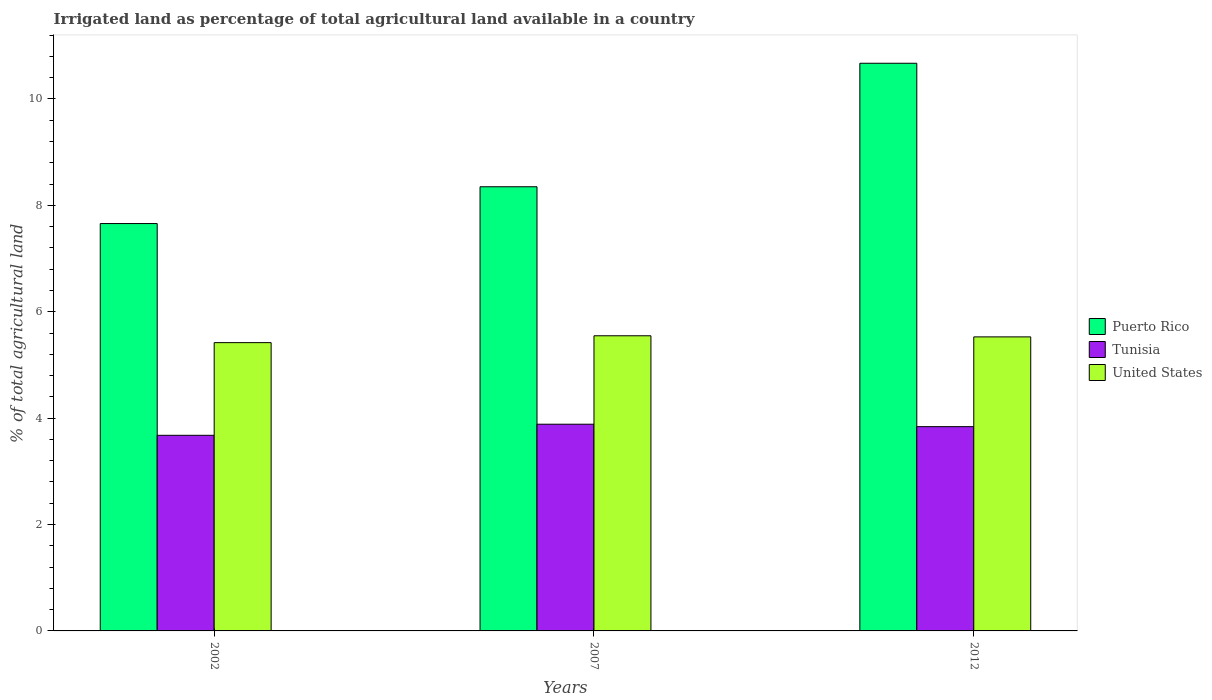Are the number of bars per tick equal to the number of legend labels?
Provide a succinct answer. Yes. Are the number of bars on each tick of the X-axis equal?
Your answer should be very brief. Yes. What is the label of the 3rd group of bars from the left?
Offer a terse response. 2012. In how many cases, is the number of bars for a given year not equal to the number of legend labels?
Your response must be concise. 0. What is the percentage of irrigated land in Tunisia in 2002?
Your response must be concise. 3.68. Across all years, what is the maximum percentage of irrigated land in Puerto Rico?
Keep it short and to the point. 10.67. Across all years, what is the minimum percentage of irrigated land in Puerto Rico?
Provide a short and direct response. 7.66. In which year was the percentage of irrigated land in United States minimum?
Offer a terse response. 2002. What is the total percentage of irrigated land in Tunisia in the graph?
Offer a terse response. 11.4. What is the difference between the percentage of irrigated land in United States in 2002 and that in 2007?
Provide a succinct answer. -0.13. What is the difference between the percentage of irrigated land in Puerto Rico in 2007 and the percentage of irrigated land in Tunisia in 2002?
Give a very brief answer. 4.67. What is the average percentage of irrigated land in Tunisia per year?
Your answer should be very brief. 3.8. In the year 2007, what is the difference between the percentage of irrigated land in Tunisia and percentage of irrigated land in United States?
Your response must be concise. -1.66. In how many years, is the percentage of irrigated land in Puerto Rico greater than 4.8 %?
Provide a succinct answer. 3. What is the ratio of the percentage of irrigated land in United States in 2007 to that in 2012?
Provide a short and direct response. 1. What is the difference between the highest and the second highest percentage of irrigated land in Tunisia?
Ensure brevity in your answer.  0.05. What is the difference between the highest and the lowest percentage of irrigated land in United States?
Offer a terse response. 0.13. In how many years, is the percentage of irrigated land in Puerto Rico greater than the average percentage of irrigated land in Puerto Rico taken over all years?
Ensure brevity in your answer.  1. What does the 2nd bar from the left in 2007 represents?
Offer a terse response. Tunisia. What does the 3rd bar from the right in 2012 represents?
Your response must be concise. Puerto Rico. How many years are there in the graph?
Offer a terse response. 3. What is the difference between two consecutive major ticks on the Y-axis?
Offer a terse response. 2. Are the values on the major ticks of Y-axis written in scientific E-notation?
Keep it short and to the point. No. How many legend labels are there?
Make the answer very short. 3. What is the title of the graph?
Provide a short and direct response. Irrigated land as percentage of total agricultural land available in a country. Does "Nepal" appear as one of the legend labels in the graph?
Your answer should be very brief. No. What is the label or title of the Y-axis?
Make the answer very short. % of total agricultural land. What is the % of total agricultural land of Puerto Rico in 2002?
Provide a succinct answer. 7.66. What is the % of total agricultural land in Tunisia in 2002?
Ensure brevity in your answer.  3.68. What is the % of total agricultural land of United States in 2002?
Offer a terse response. 5.42. What is the % of total agricultural land in Puerto Rico in 2007?
Your response must be concise. 8.35. What is the % of total agricultural land in Tunisia in 2007?
Offer a terse response. 3.89. What is the % of total agricultural land in United States in 2007?
Keep it short and to the point. 5.55. What is the % of total agricultural land in Puerto Rico in 2012?
Your response must be concise. 10.67. What is the % of total agricultural land of Tunisia in 2012?
Your answer should be very brief. 3.84. What is the % of total agricultural land in United States in 2012?
Offer a very short reply. 5.53. Across all years, what is the maximum % of total agricultural land of Puerto Rico?
Your answer should be compact. 10.67. Across all years, what is the maximum % of total agricultural land of Tunisia?
Ensure brevity in your answer.  3.89. Across all years, what is the maximum % of total agricultural land in United States?
Your answer should be compact. 5.55. Across all years, what is the minimum % of total agricultural land of Puerto Rico?
Give a very brief answer. 7.66. Across all years, what is the minimum % of total agricultural land in Tunisia?
Keep it short and to the point. 3.68. Across all years, what is the minimum % of total agricultural land of United States?
Offer a very short reply. 5.42. What is the total % of total agricultural land of Puerto Rico in the graph?
Offer a terse response. 26.68. What is the total % of total agricultural land of Tunisia in the graph?
Your answer should be compact. 11.4. What is the total % of total agricultural land in United States in the graph?
Your response must be concise. 16.49. What is the difference between the % of total agricultural land of Puerto Rico in 2002 and that in 2007?
Offer a very short reply. -0.69. What is the difference between the % of total agricultural land of Tunisia in 2002 and that in 2007?
Provide a succinct answer. -0.21. What is the difference between the % of total agricultural land in United States in 2002 and that in 2007?
Your response must be concise. -0.13. What is the difference between the % of total agricultural land of Puerto Rico in 2002 and that in 2012?
Offer a very short reply. -3.01. What is the difference between the % of total agricultural land in Tunisia in 2002 and that in 2012?
Your answer should be very brief. -0.16. What is the difference between the % of total agricultural land in United States in 2002 and that in 2012?
Your answer should be compact. -0.11. What is the difference between the % of total agricultural land in Puerto Rico in 2007 and that in 2012?
Keep it short and to the point. -2.32. What is the difference between the % of total agricultural land in Tunisia in 2007 and that in 2012?
Your response must be concise. 0.05. What is the difference between the % of total agricultural land in United States in 2007 and that in 2012?
Offer a very short reply. 0.02. What is the difference between the % of total agricultural land in Puerto Rico in 2002 and the % of total agricultural land in Tunisia in 2007?
Make the answer very short. 3.77. What is the difference between the % of total agricultural land in Puerto Rico in 2002 and the % of total agricultural land in United States in 2007?
Give a very brief answer. 2.11. What is the difference between the % of total agricultural land of Tunisia in 2002 and the % of total agricultural land of United States in 2007?
Your answer should be compact. -1.87. What is the difference between the % of total agricultural land in Puerto Rico in 2002 and the % of total agricultural land in Tunisia in 2012?
Give a very brief answer. 3.82. What is the difference between the % of total agricultural land of Puerto Rico in 2002 and the % of total agricultural land of United States in 2012?
Provide a succinct answer. 2.13. What is the difference between the % of total agricultural land of Tunisia in 2002 and the % of total agricultural land of United States in 2012?
Your answer should be compact. -1.85. What is the difference between the % of total agricultural land of Puerto Rico in 2007 and the % of total agricultural land of Tunisia in 2012?
Keep it short and to the point. 4.51. What is the difference between the % of total agricultural land in Puerto Rico in 2007 and the % of total agricultural land in United States in 2012?
Keep it short and to the point. 2.82. What is the difference between the % of total agricultural land in Tunisia in 2007 and the % of total agricultural land in United States in 2012?
Your answer should be very brief. -1.64. What is the average % of total agricultural land in Puerto Rico per year?
Your answer should be compact. 8.89. What is the average % of total agricultural land in Tunisia per year?
Your answer should be compact. 3.8. What is the average % of total agricultural land of United States per year?
Make the answer very short. 5.5. In the year 2002, what is the difference between the % of total agricultural land in Puerto Rico and % of total agricultural land in Tunisia?
Provide a short and direct response. 3.98. In the year 2002, what is the difference between the % of total agricultural land of Puerto Rico and % of total agricultural land of United States?
Keep it short and to the point. 2.24. In the year 2002, what is the difference between the % of total agricultural land of Tunisia and % of total agricultural land of United States?
Your response must be concise. -1.74. In the year 2007, what is the difference between the % of total agricultural land of Puerto Rico and % of total agricultural land of Tunisia?
Your answer should be compact. 4.46. In the year 2007, what is the difference between the % of total agricultural land of Puerto Rico and % of total agricultural land of United States?
Provide a short and direct response. 2.8. In the year 2007, what is the difference between the % of total agricultural land in Tunisia and % of total agricultural land in United States?
Ensure brevity in your answer.  -1.66. In the year 2012, what is the difference between the % of total agricultural land of Puerto Rico and % of total agricultural land of Tunisia?
Give a very brief answer. 6.83. In the year 2012, what is the difference between the % of total agricultural land in Puerto Rico and % of total agricultural land in United States?
Your response must be concise. 5.14. In the year 2012, what is the difference between the % of total agricultural land in Tunisia and % of total agricultural land in United States?
Keep it short and to the point. -1.69. What is the ratio of the % of total agricultural land in Puerto Rico in 2002 to that in 2007?
Give a very brief answer. 0.92. What is the ratio of the % of total agricultural land in Tunisia in 2002 to that in 2007?
Provide a succinct answer. 0.95. What is the ratio of the % of total agricultural land of United States in 2002 to that in 2007?
Offer a terse response. 0.98. What is the ratio of the % of total agricultural land in Puerto Rico in 2002 to that in 2012?
Give a very brief answer. 0.72. What is the ratio of the % of total agricultural land of Tunisia in 2002 to that in 2012?
Your response must be concise. 0.96. What is the ratio of the % of total agricultural land in United States in 2002 to that in 2012?
Keep it short and to the point. 0.98. What is the ratio of the % of total agricultural land in Puerto Rico in 2007 to that in 2012?
Offer a terse response. 0.78. What is the ratio of the % of total agricultural land of Tunisia in 2007 to that in 2012?
Make the answer very short. 1.01. What is the difference between the highest and the second highest % of total agricultural land of Puerto Rico?
Give a very brief answer. 2.32. What is the difference between the highest and the second highest % of total agricultural land of Tunisia?
Give a very brief answer. 0.05. What is the difference between the highest and the second highest % of total agricultural land of United States?
Offer a very short reply. 0.02. What is the difference between the highest and the lowest % of total agricultural land of Puerto Rico?
Offer a terse response. 3.01. What is the difference between the highest and the lowest % of total agricultural land in Tunisia?
Offer a terse response. 0.21. What is the difference between the highest and the lowest % of total agricultural land in United States?
Your answer should be very brief. 0.13. 